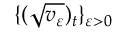<formula> <loc_0><loc_0><loc_500><loc_500>\{ ( \sqrt { v _ { \varepsilon } } ) _ { t } \} _ { \varepsilon > 0 }</formula> 